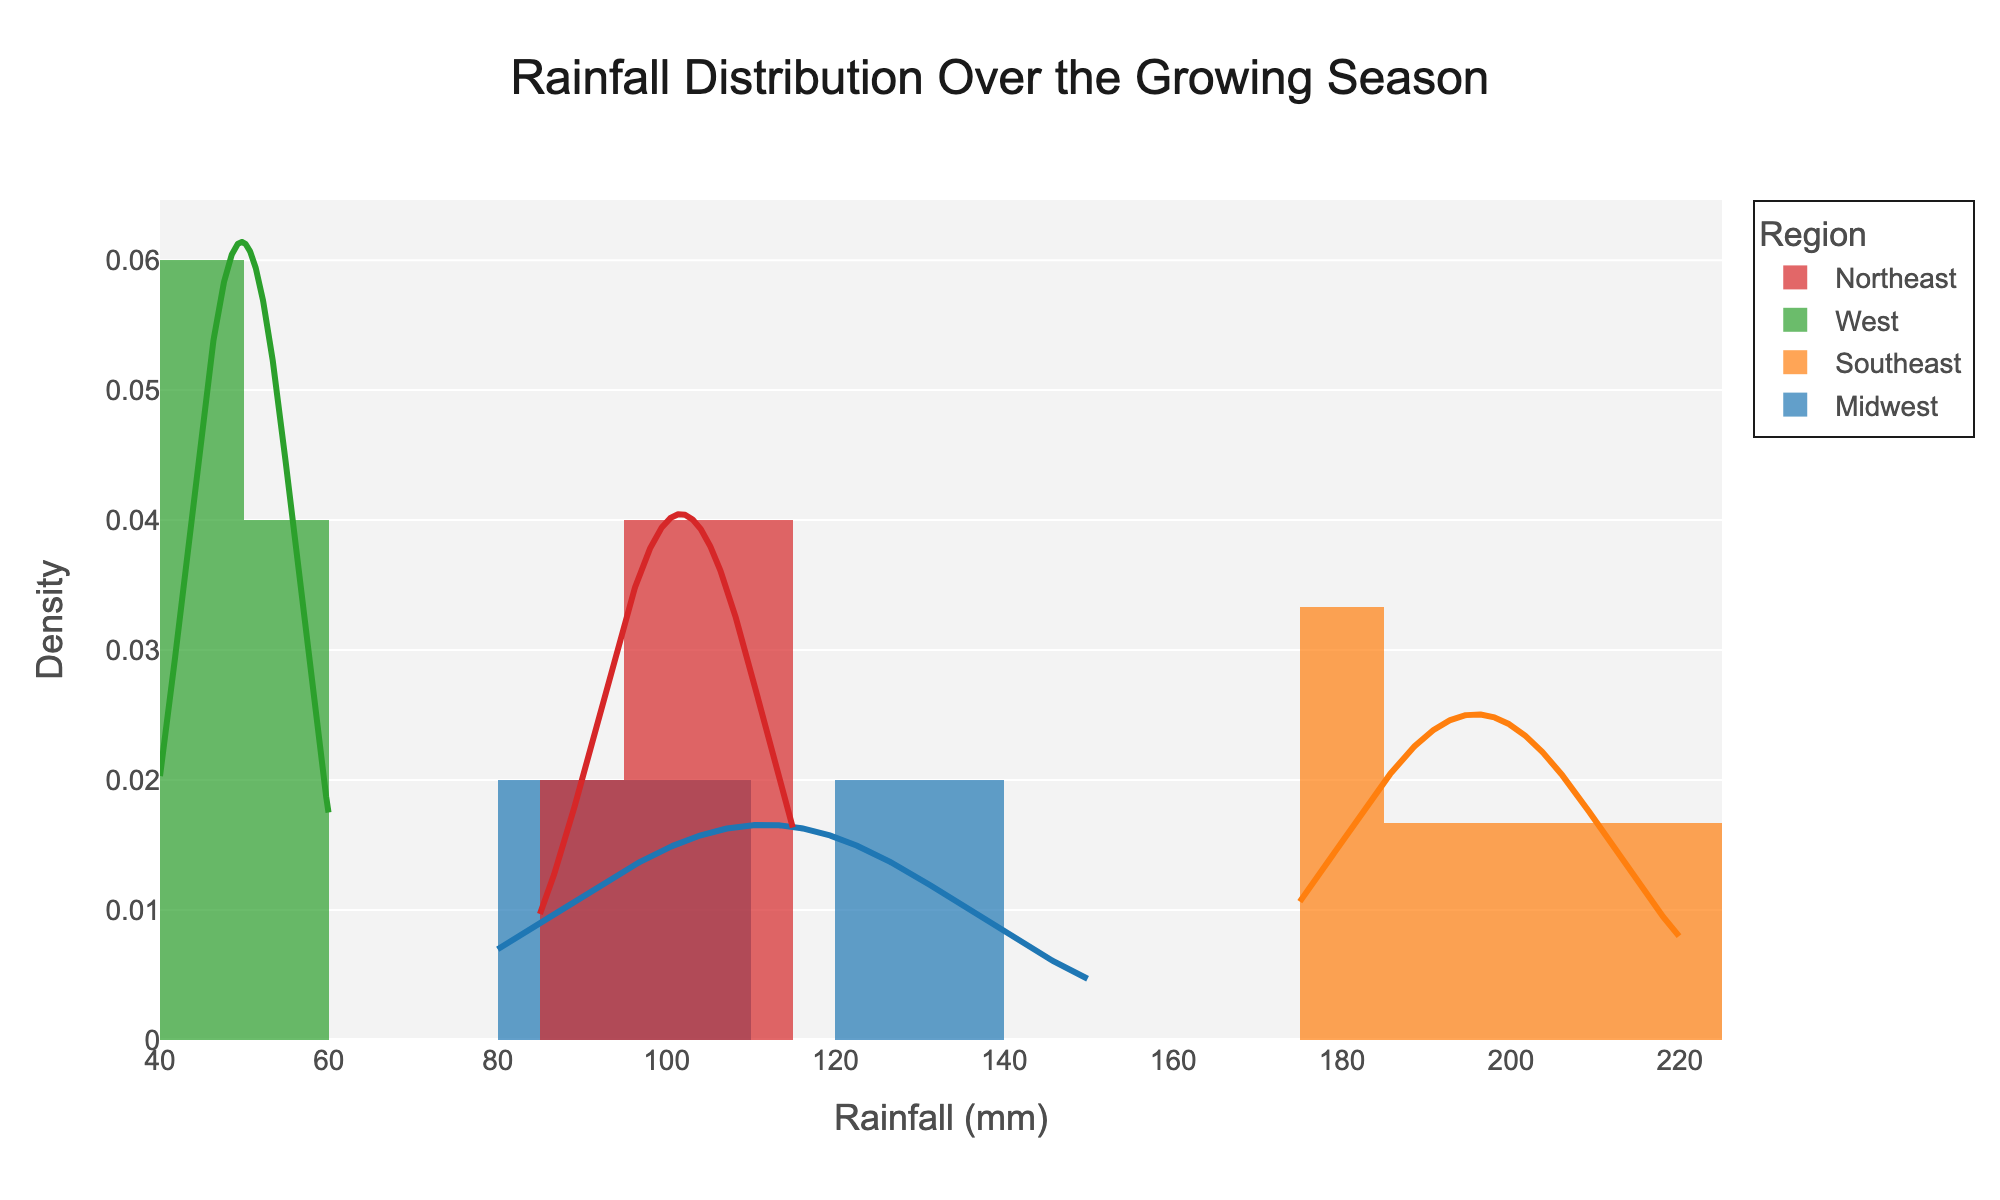What is the title of the distplot? The title of the distplot is positioned at the top of the figure, centrally aligned.
Answer: Rainfall Distribution Over the Growing Season Which region shows the highest average rainfall? By observing the density curves' peaks, the Southeast region's curve peaks at a higher rainfall value compared to other regions.
Answer: Southeast What is the range of rainfall values observed in the West region? The West region's data points can be seen from about 40 mm to 60 mm as indicated by the rainfalls near the endpoints of the density curve.
Answer: 40 mm to 60 mm Which region has the widest distribution of rainfall values? The Midwest region's density curve spans the broadest range on the x-axis, indicating a wider distribution of rainfall values.
Answer: Midwest Between the Northeast and Midwest regions, which has a higher peak density? The Northeast region's density curve peaks higher than the Midwest's density curve.
Answer: Northeast What is the approximate peak rainfall value for the Northeast region? The peak of the density curve for the Northeast region occurs around 100 mm of rainfall.
Answer: 100 mm Which region's density curve indicates the least variability in rainfall? The West region's density curve is narrow and centered, showing the least variability in rainfall.
Answer: West Is there any region with a bimodal distribution? Examining the shapes of the density curves, none of the regions display a bimodal distribution; they all have a single peak.
Answer: No How does the average rainfall in the Midwest compare to the average rainfall in the Northeast? Both regions have density curves peaking near similar rainfall values around 100 mm; thus, their average rainfall is relatively close.
Answer: Similar Which region is most likely to experience rainfall around 130 mm? The Midwest region has a portion of its density curve around 130 mm, implying it often experiences this amount of rainfall.
Answer: Midwest 